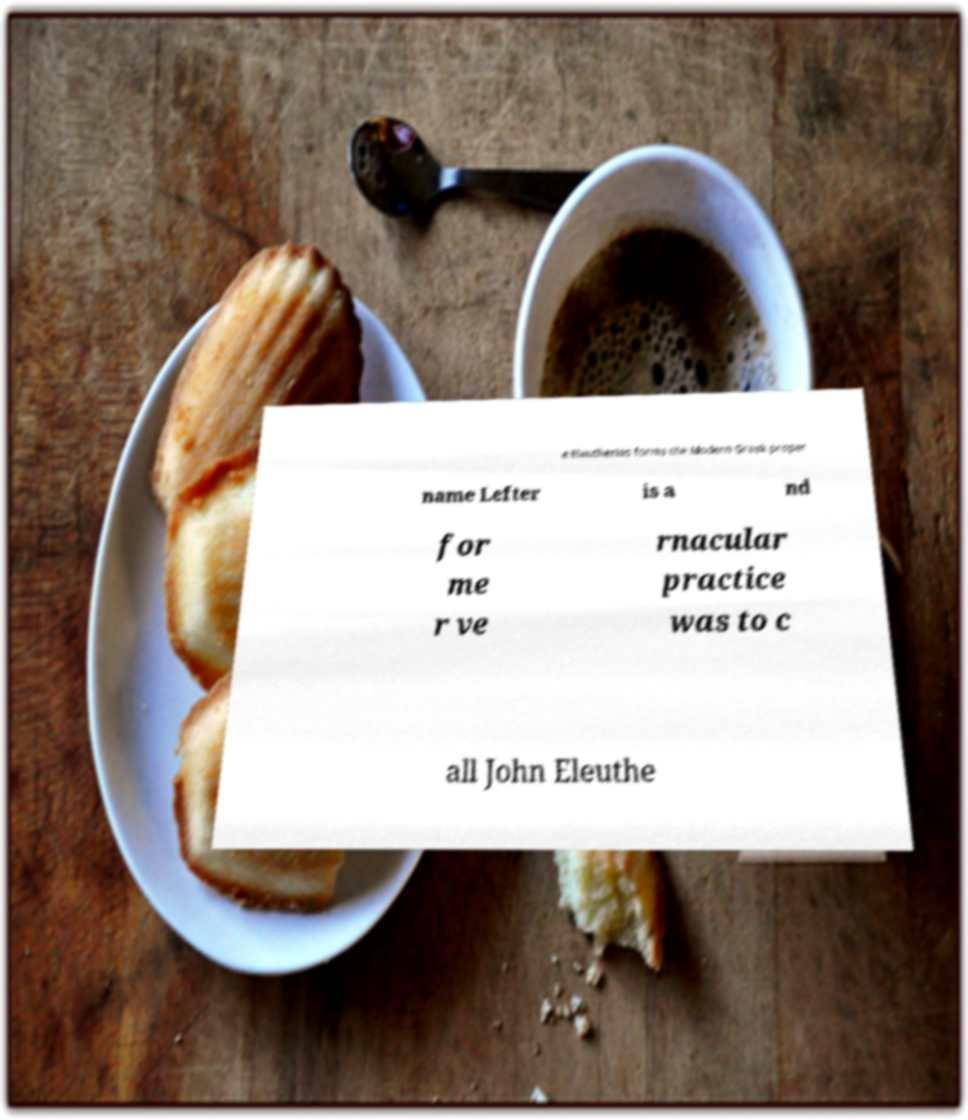I need the written content from this picture converted into text. Can you do that? e Eleutherios forms the Modern Greek proper name Lefter is a nd for me r ve rnacular practice was to c all John Eleuthe 